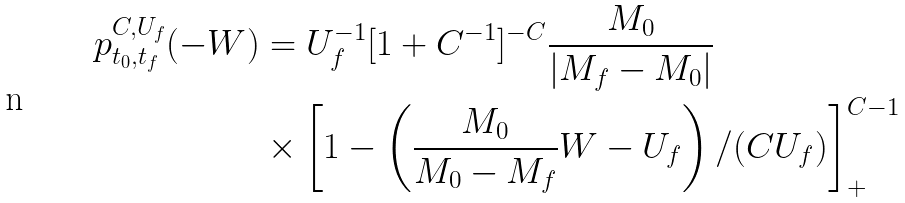<formula> <loc_0><loc_0><loc_500><loc_500>p _ { t _ { 0 } , t _ { f } } ^ { C , U _ { f } } ( - W ) & = U _ { f } ^ { - 1 } [ 1 + C ^ { - 1 } ] ^ { - C } \frac { M _ { 0 } } { | M _ { f } - M _ { 0 } | } \\ & \times \left [ 1 - \left ( \frac { M _ { 0 } } { M _ { 0 } - M _ { f } } W - U _ { f } \right ) / ( { C U _ { f } } ) \right ] ^ { C - 1 } _ { + }</formula> 